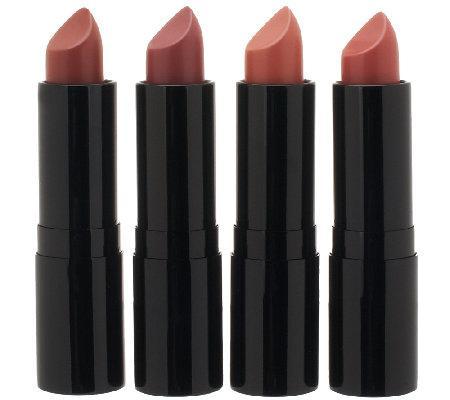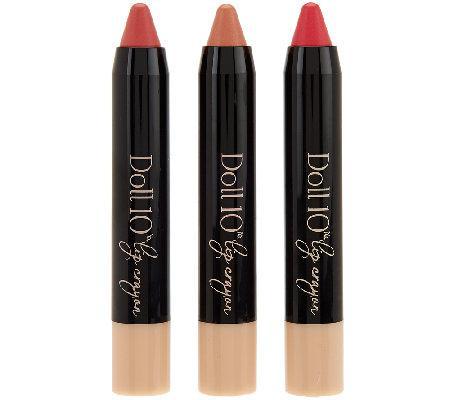The first image is the image on the left, the second image is the image on the right. For the images displayed, is the sentence "An image with three lip cosmetics includes at least one product shaped like a crayon." factually correct? Answer yes or no. Yes. The first image is the image on the left, the second image is the image on the right. Analyze the images presented: Is the assertion "Only one lipstick cap is shown right next to a lipstick." valid? Answer yes or no. No. 